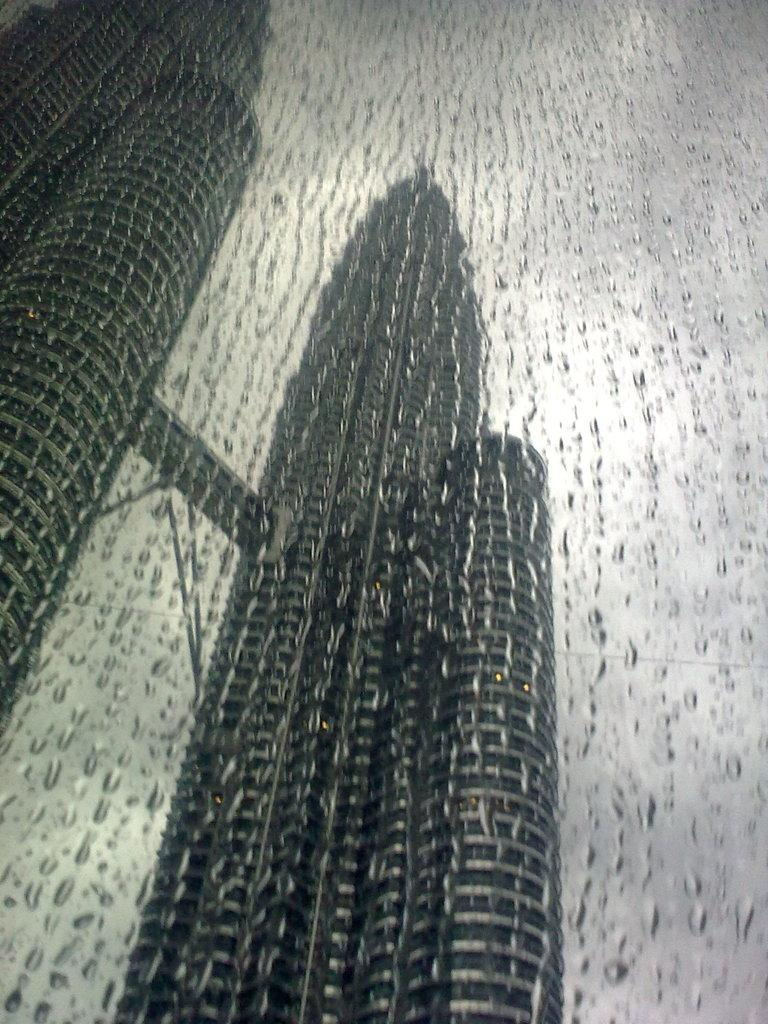What can be seen on the glass in the image? There are water drops on the glass in the image. What is visible behind the glass? There are buildings visible behind the glass. What type of lace is being used to create the water drops on the glass in the image? There is no lace present in the image; the water drops are formed naturally on the glass. 